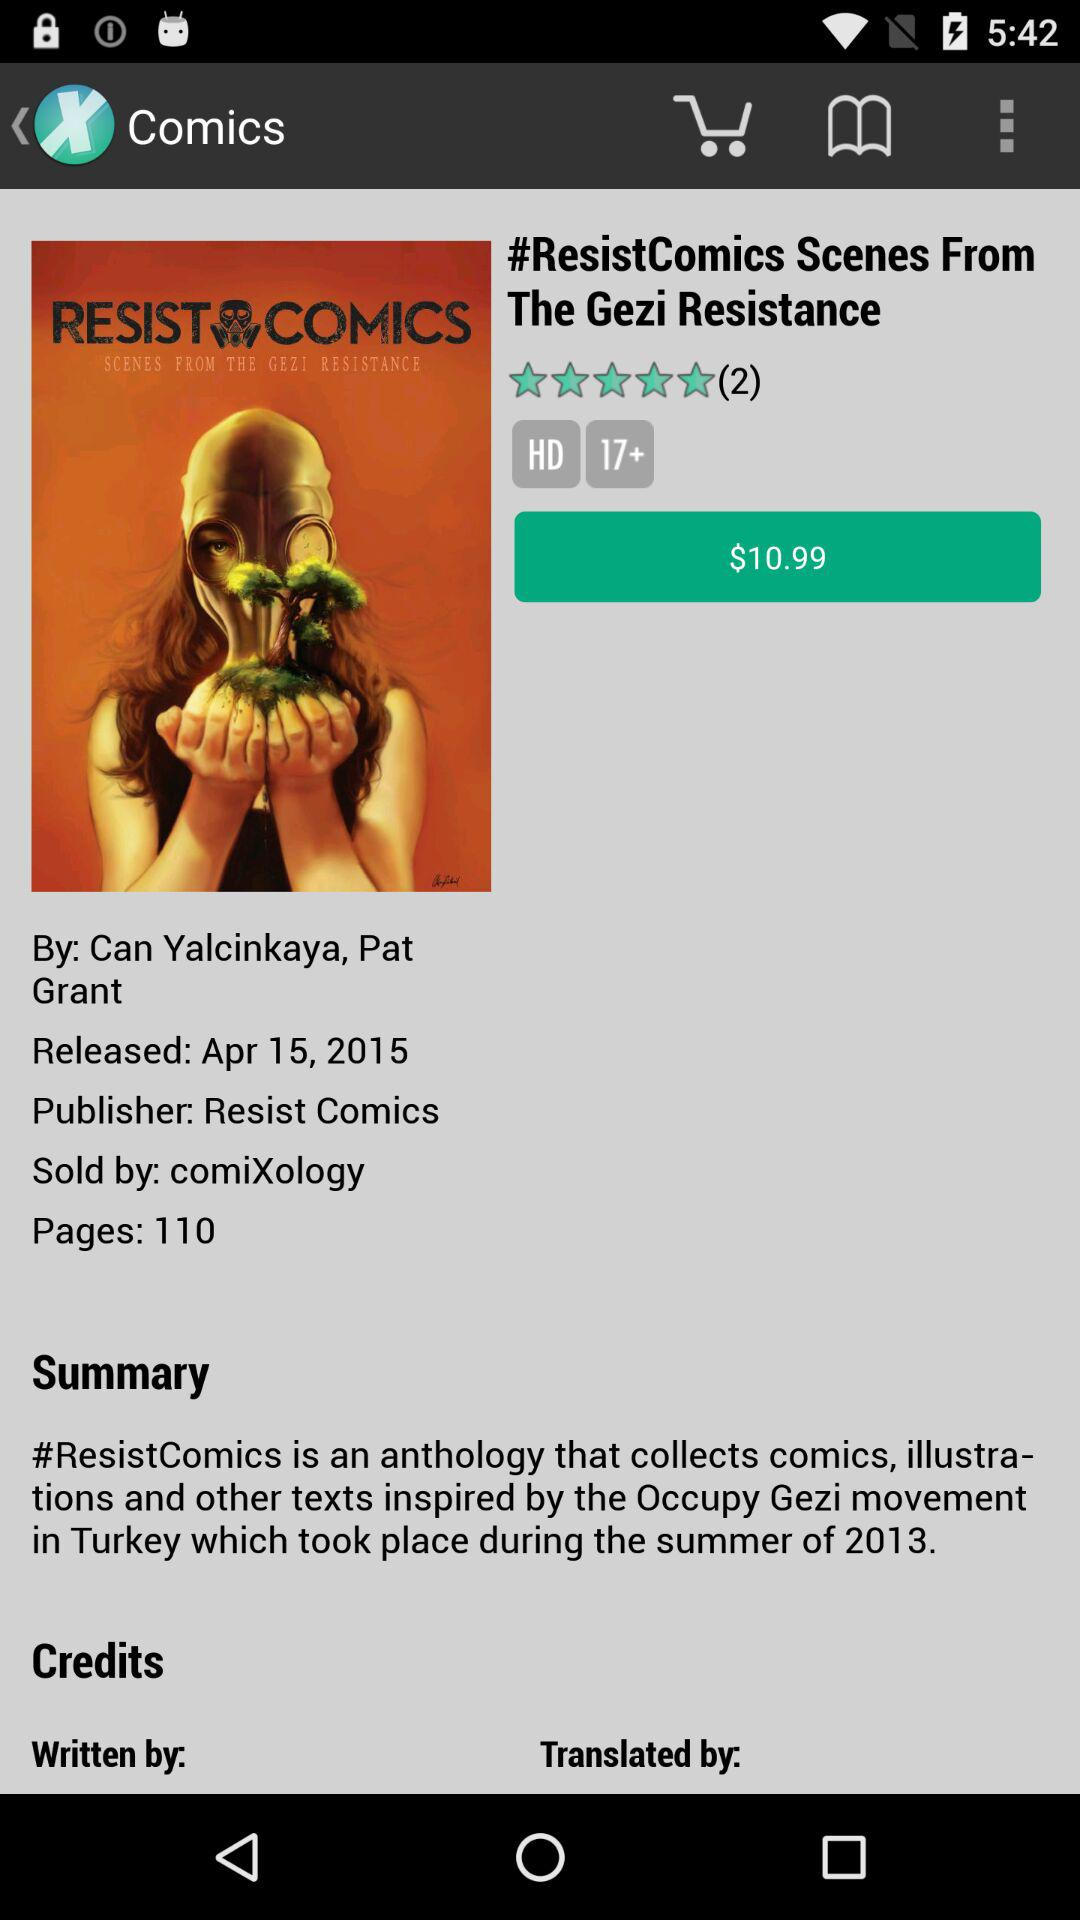How many pages does the book have?
Answer the question using a single word or phrase. 110 